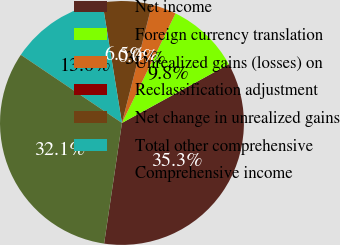<chart> <loc_0><loc_0><loc_500><loc_500><pie_chart><fcel>Net income<fcel>Foreign currency translation<fcel>Unrealized gains (losses) on<fcel>Reclassification adjustment<fcel>Net change in unrealized gains<fcel>Total other comprehensive<fcel>Comprehensive income<nl><fcel>35.34%<fcel>9.76%<fcel>3.27%<fcel>0.02%<fcel>6.51%<fcel>13.0%<fcel>32.1%<nl></chart> 